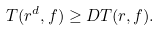Convert formula to latex. <formula><loc_0><loc_0><loc_500><loc_500>T ( r ^ { d } , f ) \geq D T ( r , f ) .</formula> 